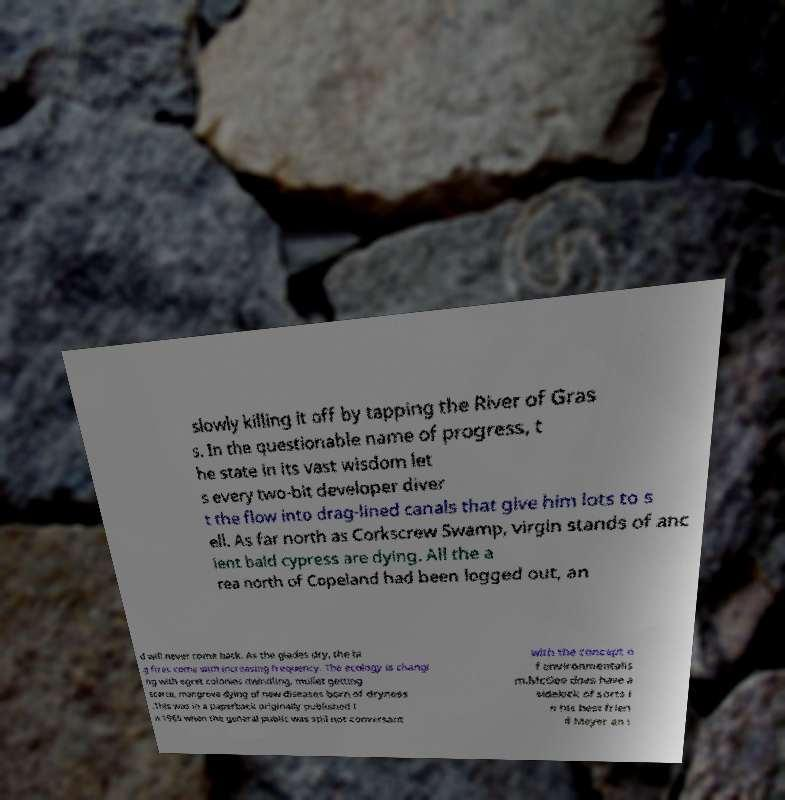I need the written content from this picture converted into text. Can you do that? slowly killing it off by tapping the River of Gras s. In the questionable name of progress, t he state in its vast wisdom let s every two-bit developer diver t the flow into drag-lined canals that give him lots to s ell. As far north as Corkscrew Swamp, virgin stands of anc ient bald cypress are dying. All the a rea north of Copeland had been logged out, an d will never come back. As the glades dry, the bi g fires come with increasing frequency. The ecology is changi ng with egret colonies dwindling, mullet getting scarce, mangrove dying of new diseases born of dryness .This was in a paperback originally published i n 1965 when the general public was still not conversant with the concept o f environmentalis m.McGee does have a sidekick of sorts i n his best frien d Meyer an i 